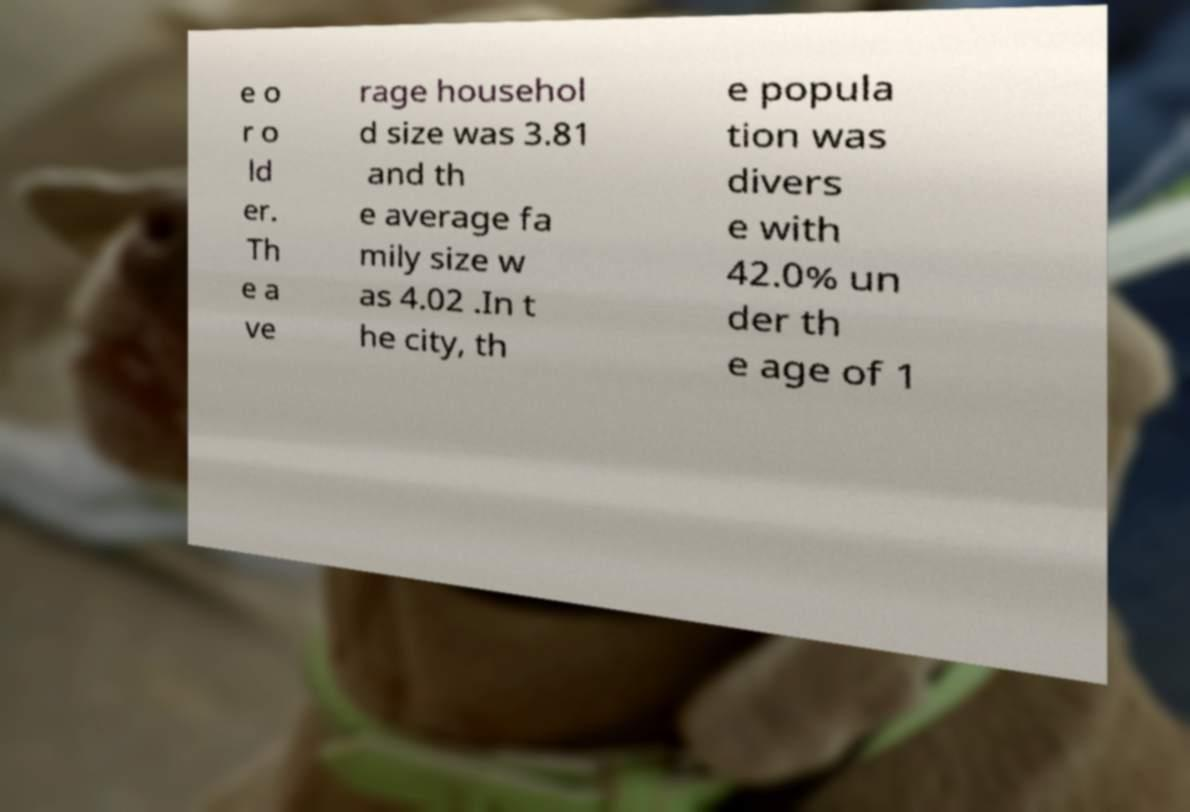Could you assist in decoding the text presented in this image and type it out clearly? e o r o ld er. Th e a ve rage househol d size was 3.81 and th e average fa mily size w as 4.02 .In t he city, th e popula tion was divers e with 42.0% un der th e age of 1 